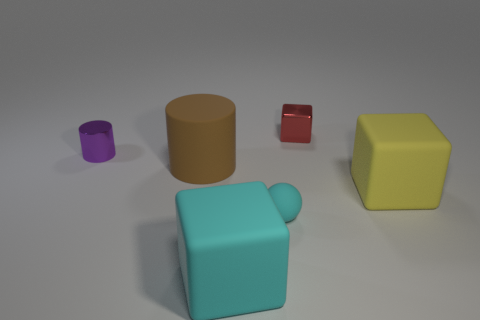What is the material of the object that is the same color as the matte sphere?
Your answer should be compact. Rubber. Is there another tiny red shiny thing that has the same shape as the small red metal object?
Your response must be concise. No. Is the big cube that is behind the tiny rubber ball made of the same material as the block behind the yellow object?
Offer a terse response. No. There is a metallic cube to the right of the tiny object in front of the rubber object to the right of the tiny cyan matte ball; what size is it?
Offer a terse response. Small. What is the material of the brown cylinder that is the same size as the cyan matte cube?
Provide a succinct answer. Rubber. Is there a purple metal thing that has the same size as the cyan sphere?
Offer a terse response. Yes. Is the shape of the big brown matte object the same as the purple shiny thing?
Your answer should be very brief. Yes. Are there any big brown rubber objects behind the tiny metallic object on the left side of the cube that is in front of the yellow rubber thing?
Provide a succinct answer. No. What number of other objects are the same color as the small rubber ball?
Give a very brief answer. 1. Do the cylinder right of the purple metal cylinder and the shiny thing that is right of the brown cylinder have the same size?
Your answer should be compact. No. 